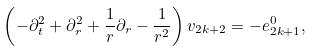Convert formula to latex. <formula><loc_0><loc_0><loc_500><loc_500>\left ( - \partial _ { t } ^ { 2 } + \partial _ { r } ^ { 2 } + \frac { 1 } { r } \partial _ { r } - \frac { 1 } { r ^ { 2 } } \right ) v _ { 2 k + 2 } = - e _ { 2 k + 1 } ^ { 0 } ,</formula> 